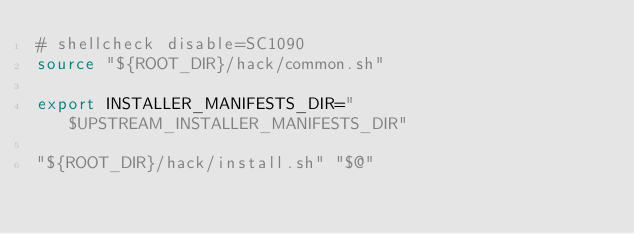<code> <loc_0><loc_0><loc_500><loc_500><_Bash_># shellcheck disable=SC1090
source "${ROOT_DIR}/hack/common.sh"

export INSTALLER_MANIFESTS_DIR="$UPSTREAM_INSTALLER_MANIFESTS_DIR"

"${ROOT_DIR}/hack/install.sh" "$@"
</code> 